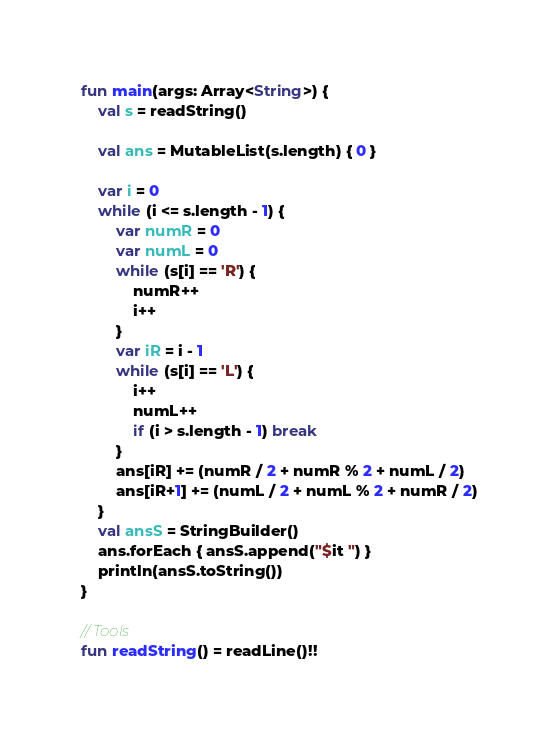<code> <loc_0><loc_0><loc_500><loc_500><_Kotlin_>fun main(args: Array<String>) {
    val s = readString()

    val ans = MutableList(s.length) { 0 }

    var i = 0
    while (i <= s.length - 1) {
        var numR = 0
        var numL = 0
        while (s[i] == 'R') {
            numR++
            i++
        }
        var iR = i - 1
        while (s[i] == 'L') {
            i++
            numL++
            if (i > s.length - 1) break
        }
        ans[iR] += (numR / 2 + numR % 2 + numL / 2)
        ans[iR+1] += (numL / 2 + numL % 2 + numR / 2)
    }
    val ansS = StringBuilder()
    ans.forEach { ansS.append("$it ") }
    println(ansS.toString())
}

// Tools
fun readString() = readLine()!!</code> 